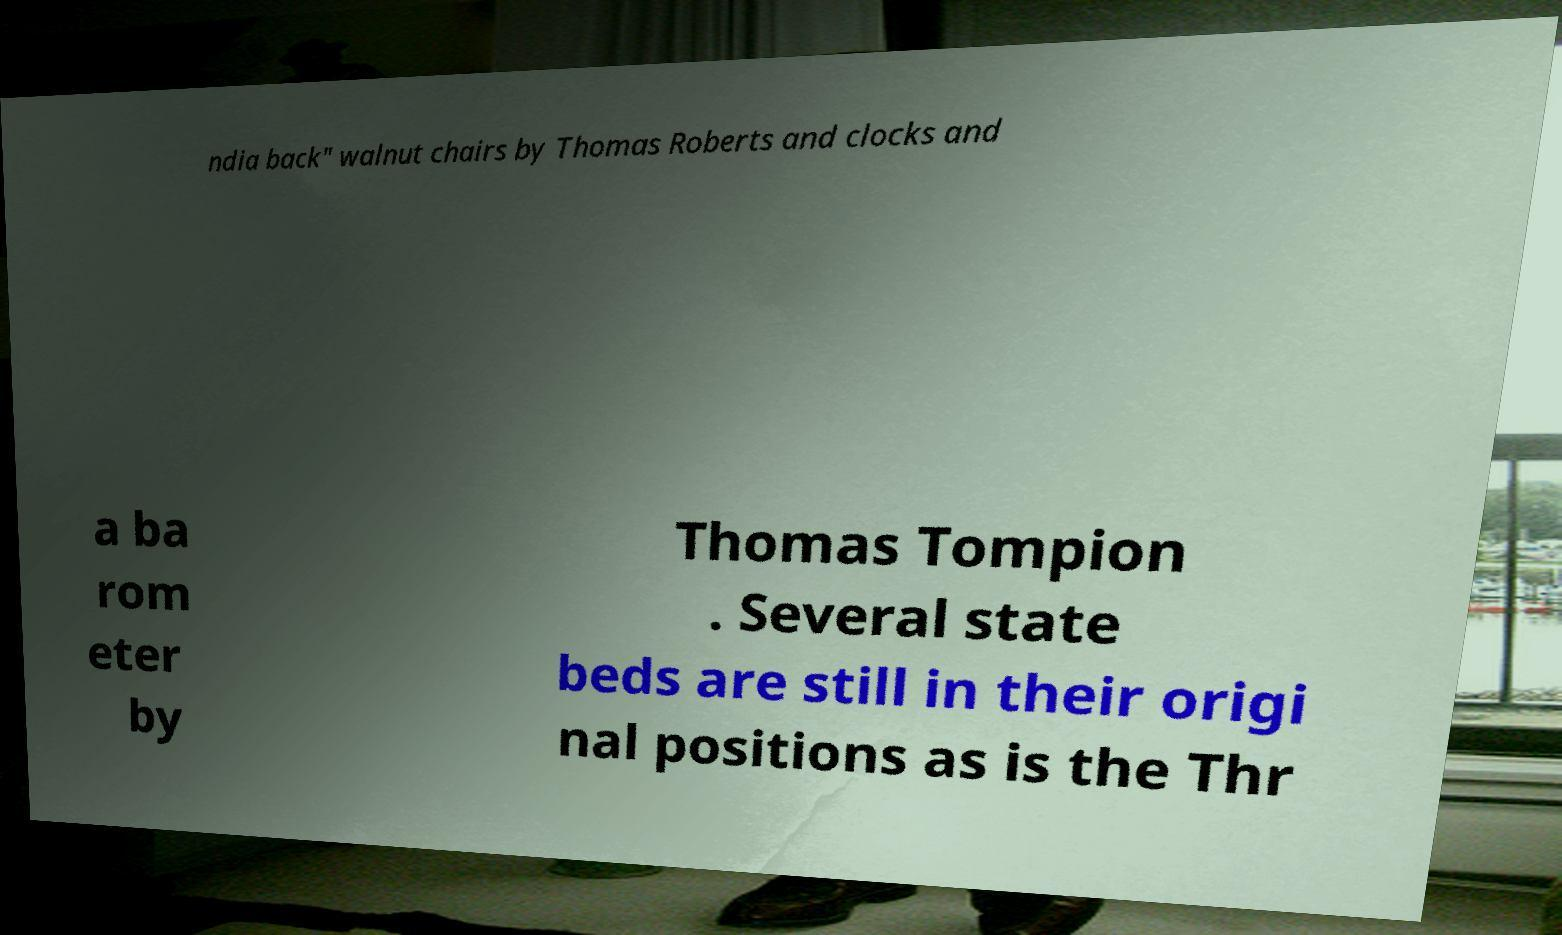Can you accurately transcribe the text from the provided image for me? ndia back" walnut chairs by Thomas Roberts and clocks and a ba rom eter by Thomas Tompion . Several state beds are still in their origi nal positions as is the Thr 